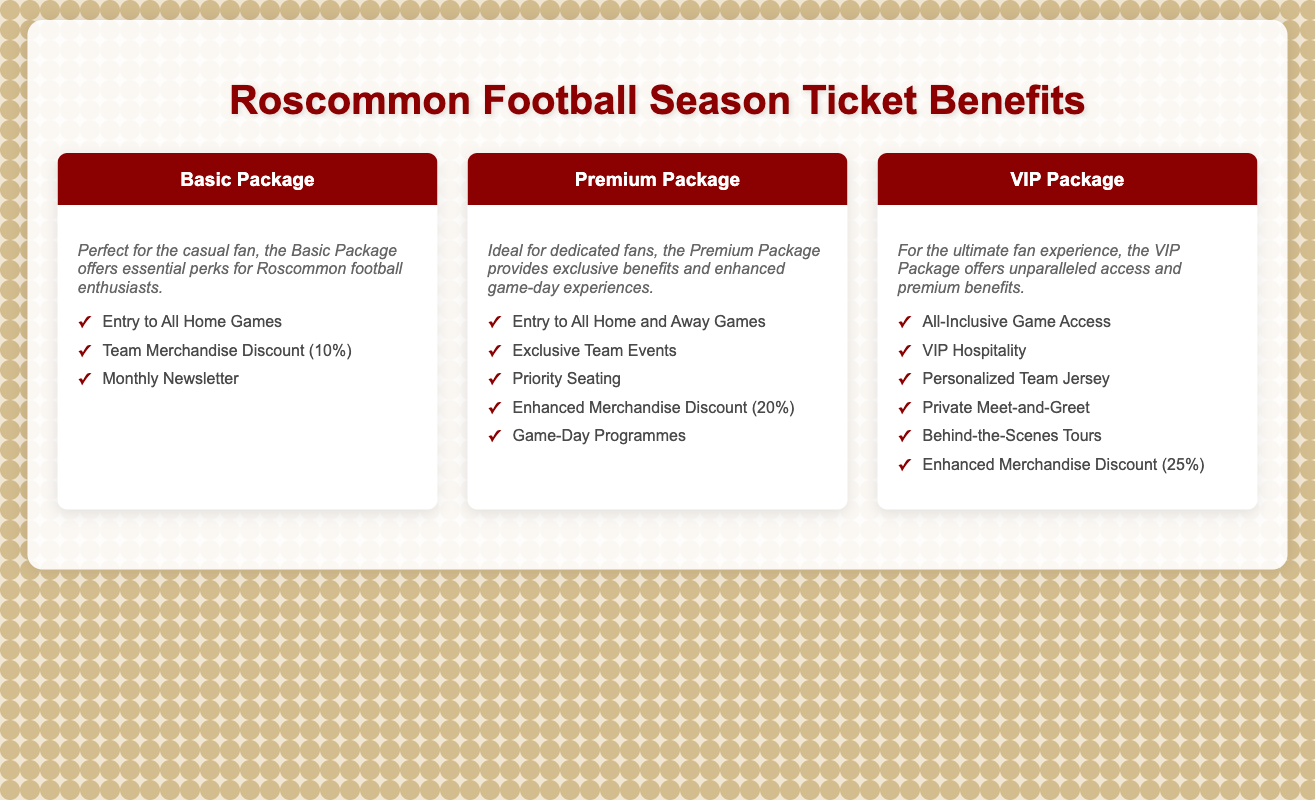What are the packages available? The document lists three packages: Basic Package, Premium Package, and VIP Package.
Answer: Basic, Premium, VIP What is the discount for the Premium Package? The Premium Package includes an enhanced merchandise discount of 20%.
Answer: 20% What is included in the Basic Package? The Basic Package includes entry to all home games, a 10% team merchandise discount, and a monthly newsletter.
Answer: Entry to All Home Games, Team Merchandise Discount (10%), Monthly Newsletter How many games can Premium Package holders attend? Premium Package holders have access to all home and away games.
Answer: All Home and Away Games What unique perk does the VIP Package offer? The VIP Package includes a private meet-and-greet.
Answer: Private Meet-and-Greet What is the merchandise discount for the VIP Package? The VIP Package offers an enhanced merchandise discount of 25%.
Answer: 25% Which package is perfect for casual fans? The Basic Package is described as perfect for casual fans.
Answer: Basic Package How does the Premium Package enhance the game-day experience? The Premium Package provides exclusive team events, priority seating, and game-day programmes.
Answer: Exclusive Team Events, Priority Seating, Game-Day Programmes 